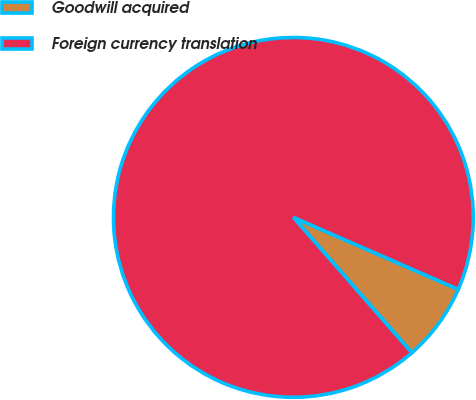<chart> <loc_0><loc_0><loc_500><loc_500><pie_chart><fcel>Goodwill acquired<fcel>Foreign currency translation<nl><fcel>7.01%<fcel>92.99%<nl></chart> 